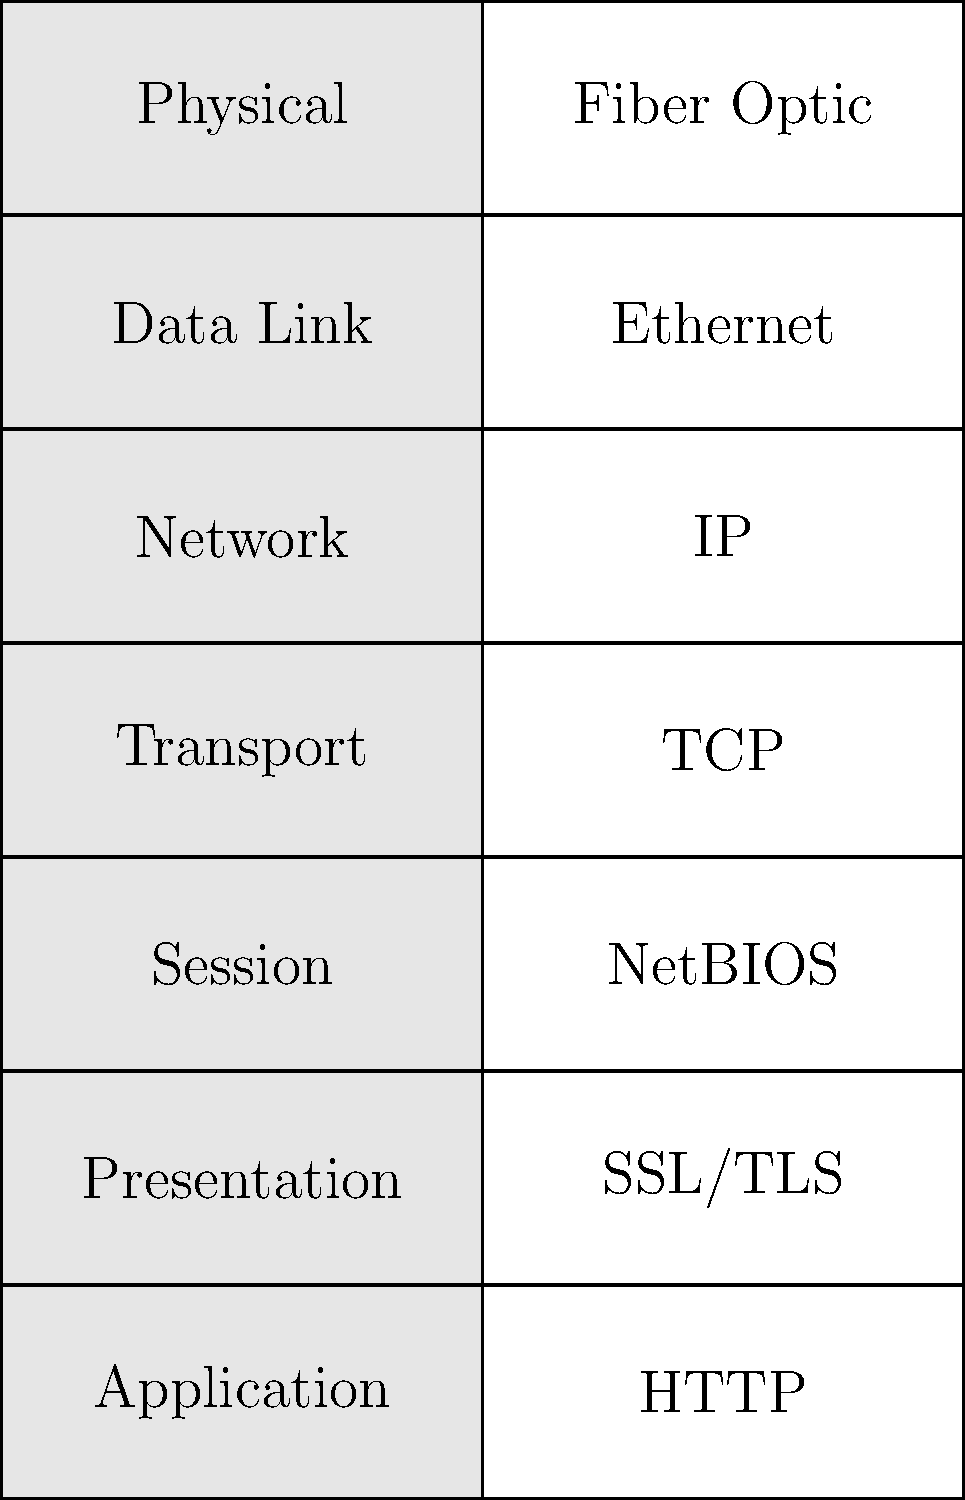Match the network protocols on the right side of the diagram to their corresponding OSI layers on the left side. Which protocol is associated with the Network layer? To answer this question, we need to understand the OSI (Open Systems Interconnection) model and its layers, as well as the common protocols associated with each layer. Let's go through the layers and protocols step-by-step:

1. Physical Layer: This is the lowest layer, dealing with the physical transmission of data. The protocol shown for this layer is Fiber Optic, which is correct.

2. Data Link Layer: This layer is responsible for node-to-node data transfer. The protocol shown is Ethernet, which is correct.

3. Network Layer: This layer handles routing and forwarding of data packets. The protocol shown is IP (Internet Protocol), which is correct and is the answer to our question.

4. Transport Layer: This layer ensures end-to-end communication and data flow control. The protocol shown is TCP (Transmission Control Protocol), which is correct.

5. Session Layer: This layer establishes, manages, and terminates sessions between applications. The protocol shown is NetBIOS, which is correct.

6. Presentation Layer: This layer handles data formatting, encryption, and compression. The protocol shown is SSL/TLS (Secure Sockets Layer/Transport Layer Security), which is correct.

7. Application Layer: This is the topmost layer, closest to the end-user, handling application-specific protocols. The protocol shown is HTTP (Hypertext Transfer Protocol), which is correct.

Therefore, the protocol associated with the Network layer is IP (Internet Protocol).
Answer: IP (Internet Protocol) 